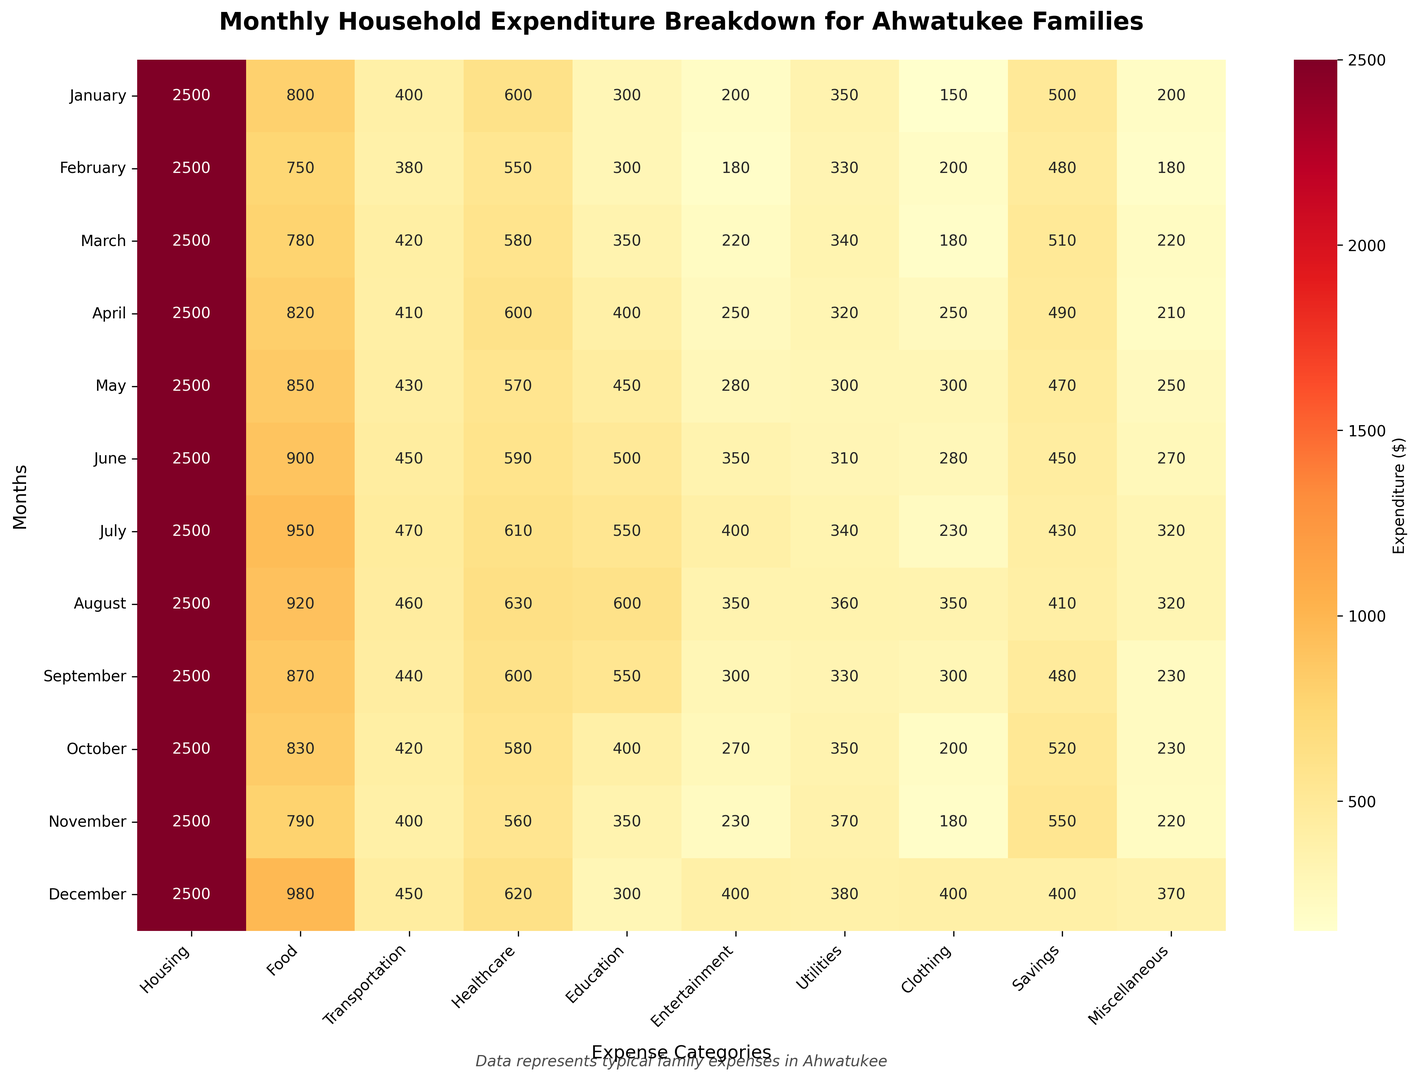What's the total expenditure on Food in the first quarter (January to March)? Sum the values for Food from January, February, and March: \(800 + 750 + 780 = 2330\)
Answer: 2330 How does the Housing expenditure compare across all months? The Housing expenditure is consistently $2500 across all months, which you can verify by seeing the same value for all rows under the Housing column.
Answer: It remains the same Which category has the most variation in expenditure across months? To find the variation, look for categories where the values change significantly month-to-month. Housing remains constant, while categories like Entertainment (200 to 400), Clothing (150 to 400), and Food (750 to 980) show more variation.
Answer: Food Which month had the lowest expenditure on Entertainment, and how much? Compare the values in the Entertainment column across all months. February has the smallest value for Entertainment, which is 180.
Answer: February, 180 